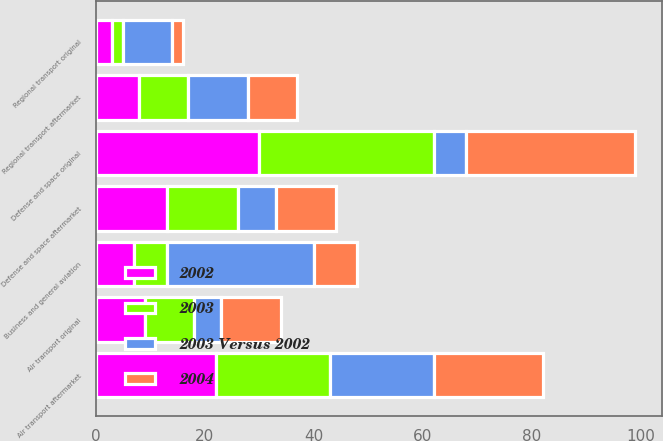Convert chart. <chart><loc_0><loc_0><loc_500><loc_500><stacked_bar_chart><ecel><fcel>Air transport aftermarket<fcel>Air transport original<fcel>Regional transport aftermarket<fcel>Regional transport original<fcel>Business and general aviation<fcel>Defense and space aftermarket<fcel>Defense and space original<nl><fcel>2002<fcel>22<fcel>9<fcel>8<fcel>3<fcel>7<fcel>13<fcel>30<nl><fcel>2003<fcel>21<fcel>9<fcel>9<fcel>2<fcel>6<fcel>13<fcel>32<nl><fcel>2004<fcel>20<fcel>11<fcel>9<fcel>2<fcel>8<fcel>11<fcel>31<nl><fcel>2003 Versus 2002<fcel>19<fcel>5<fcel>11<fcel>9<fcel>27<fcel>7<fcel>6<nl></chart> 